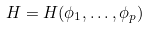<formula> <loc_0><loc_0><loc_500><loc_500>H = H ( \phi _ { 1 } , \dots , \phi _ { p } )</formula> 